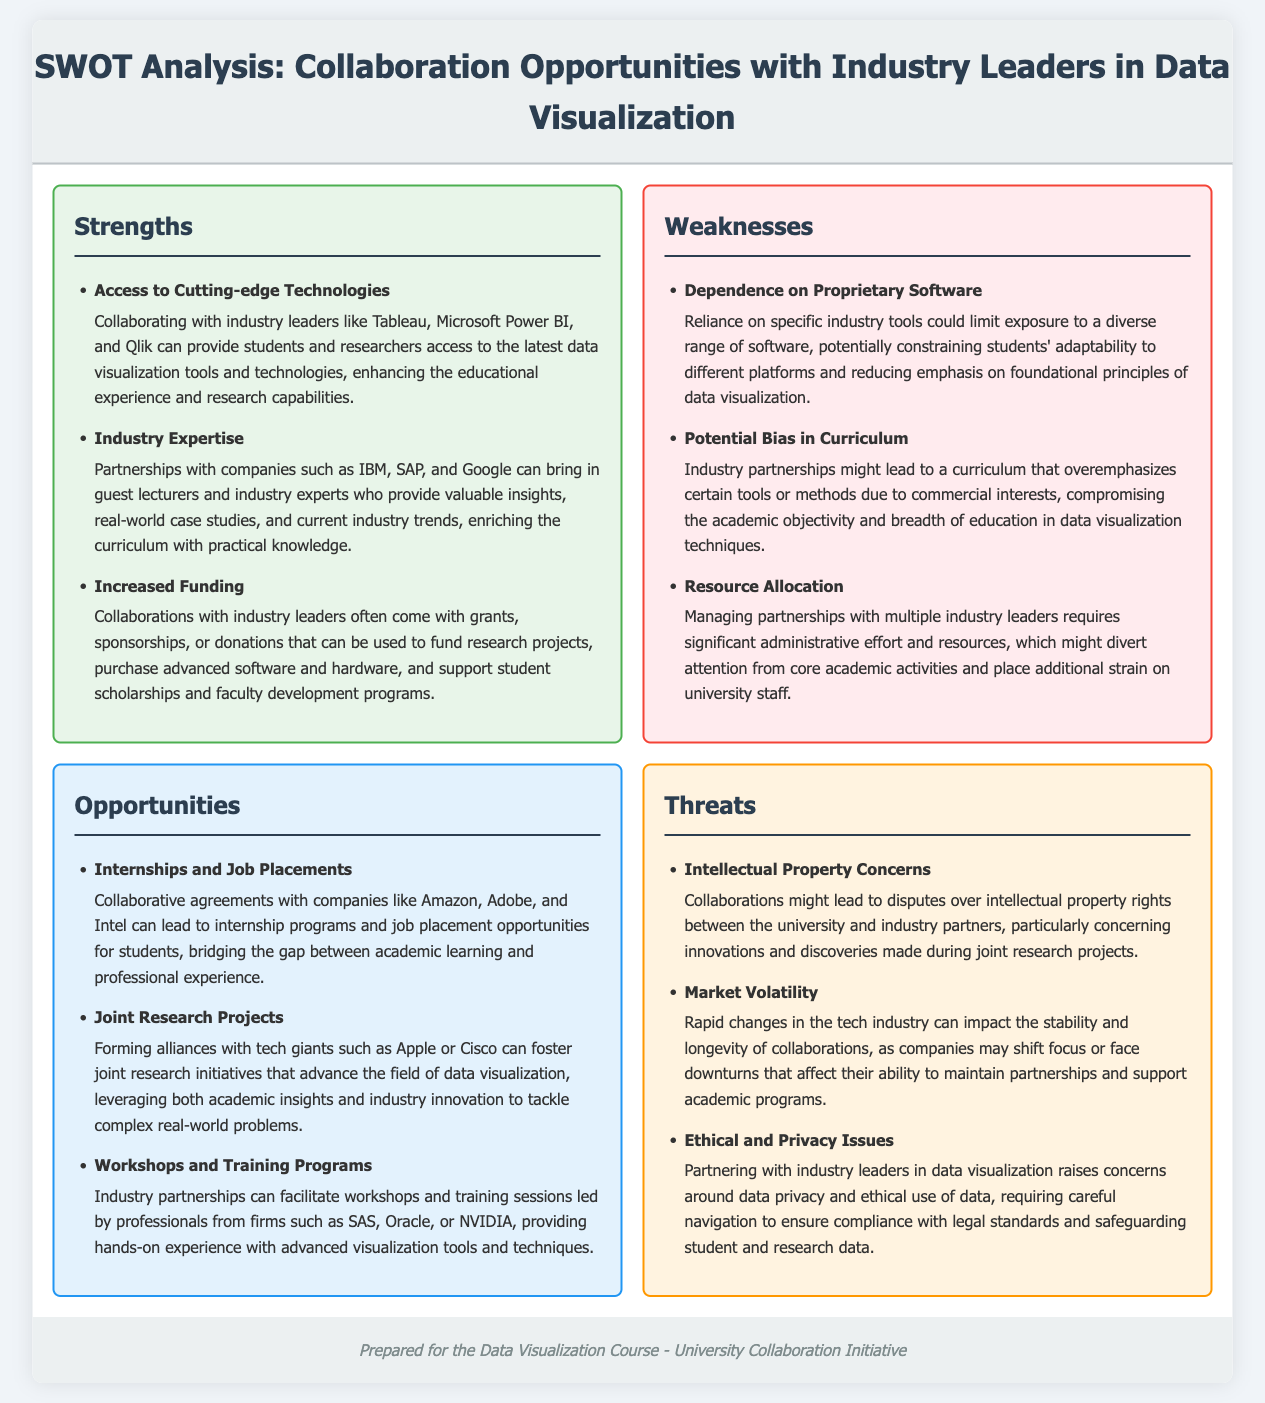what are the three main strengths outlined in the document? The strengths listed include "Access to Cutting-edge Technologies," "Industry Expertise," and "Increased Funding."
Answer: Access to Cutting-edge Technologies, Industry Expertise, Increased Funding which industry partnerships could lead to job placements for students? The document mentions partnerships with companies such as Amazon, Adobe, and Intel for job placements.
Answer: Amazon, Adobe, and Intel what is a potential bias issue mentioned in the weaknesses section? The weaknesses section highlights the concern of "Potential Bias in Curriculum," which might compromise academic objectivity.
Answer: Potential Bias in Curriculum what are two threats associated with collaborations? The threats section lists "Intellectual Property Concerns" and "Market Volatility" as two key threats.
Answer: Intellectual Property Concerns, Market Volatility which technology companies are suggested for joint research projects? Companies like Apple and Cisco are mentioned in the opportunities section for joint research projects.
Answer: Apple, Cisco what administrative challenge is indicated under weaknesses? The document states that managing partnerships requires "significant administrative effort and resources."
Answer: significant administrative effort and resources how might industry collaborations enhance the educational experience? The strengths section states that collaborations can provide access to "the latest data visualization tools and technologies."
Answer: the latest data visualization tools and technologies what type of training programs can be facilitated by industry partnerships? The document mentions that industry partnerships can facilitate "workshops and training sessions."
Answer: workshops and training sessions 